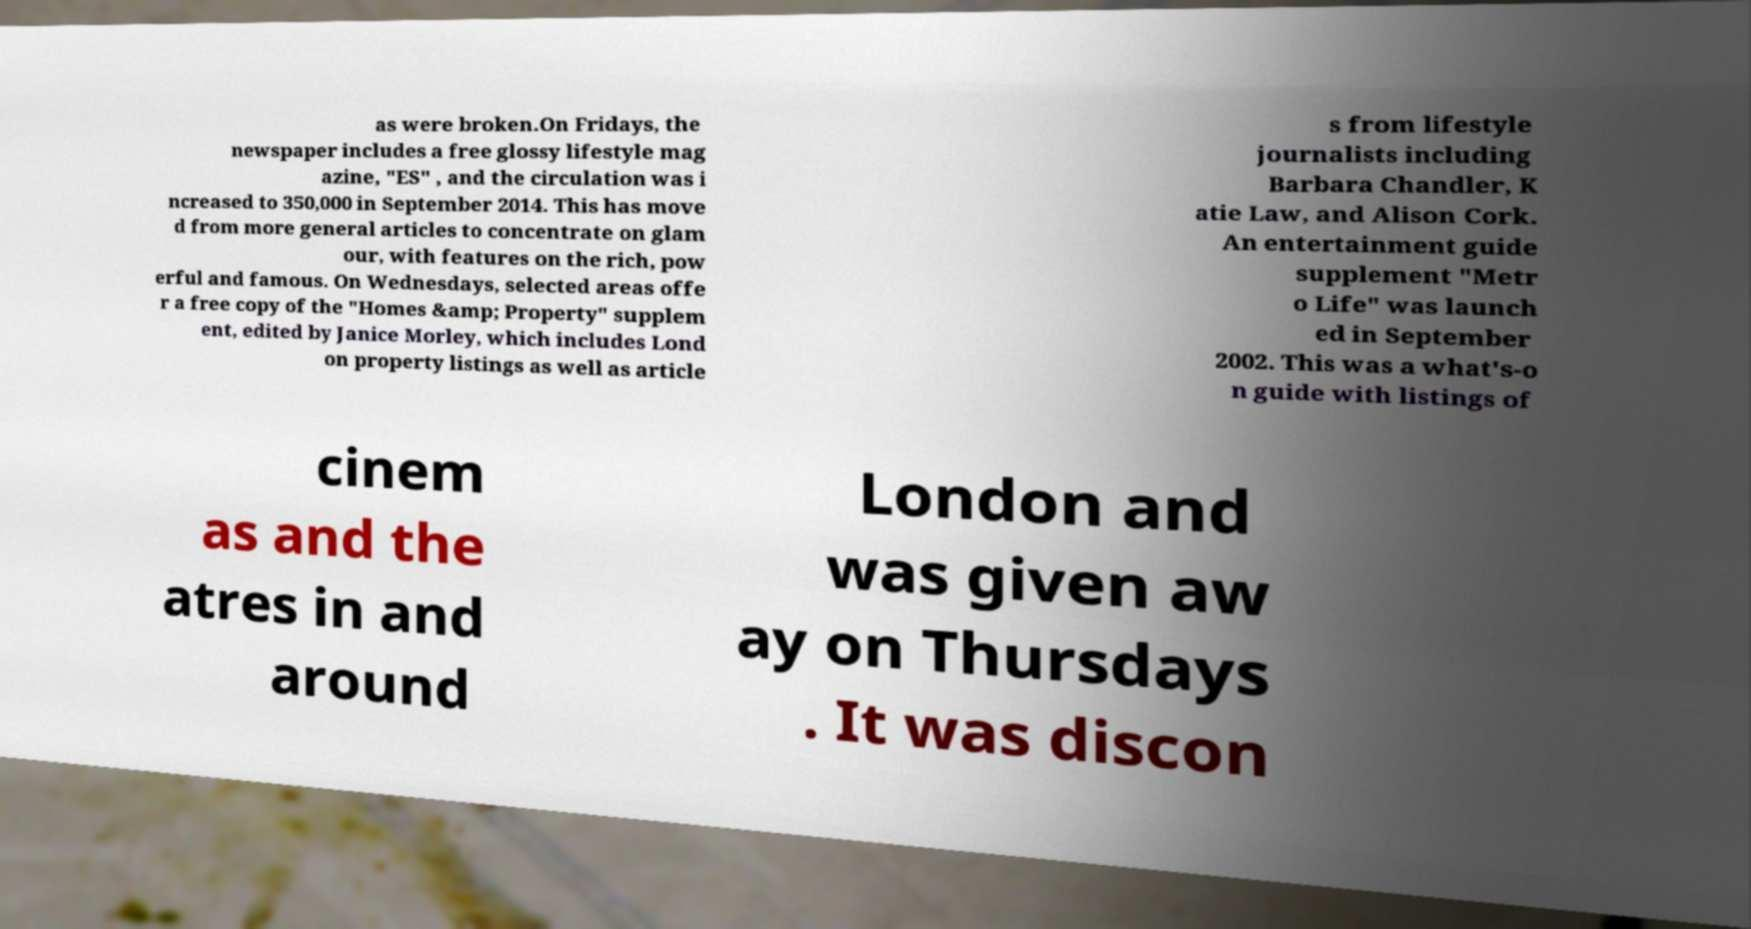Can you accurately transcribe the text from the provided image for me? as were broken.On Fridays, the newspaper includes a free glossy lifestyle mag azine, "ES" , and the circulation was i ncreased to 350,000 in September 2014. This has move d from more general articles to concentrate on glam our, with features on the rich, pow erful and famous. On Wednesdays, selected areas offe r a free copy of the "Homes &amp; Property" supplem ent, edited by Janice Morley, which includes Lond on property listings as well as article s from lifestyle journalists including Barbara Chandler, K atie Law, and Alison Cork. An entertainment guide supplement "Metr o Life" was launch ed in September 2002. This was a what's-o n guide with listings of cinem as and the atres in and around London and was given aw ay on Thursdays . It was discon 